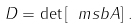Convert formula to latex. <formula><loc_0><loc_0><loc_500><loc_500>D = \det \left [ \ m s b { A } \right ] \, .</formula> 